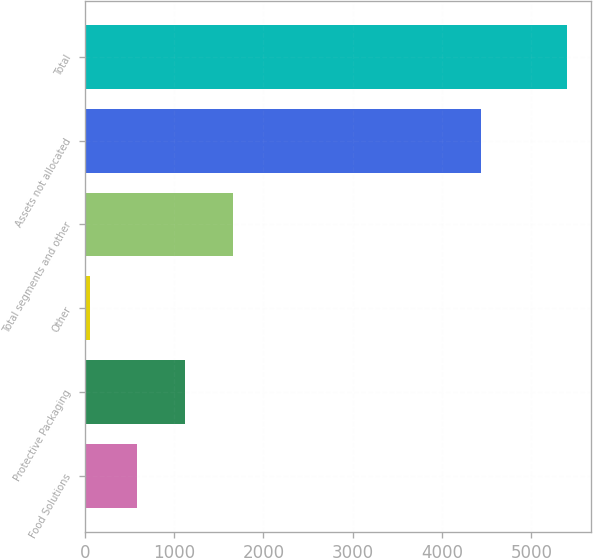Convert chart. <chart><loc_0><loc_0><loc_500><loc_500><bar_chart><fcel>Food Solutions<fcel>Protective Packaging<fcel>Other<fcel>Total segments and other<fcel>Assets not allocated<fcel>Total<nl><fcel>589.35<fcel>1123.8<fcel>54.9<fcel>1658.25<fcel>4432.1<fcel>5399.4<nl></chart> 